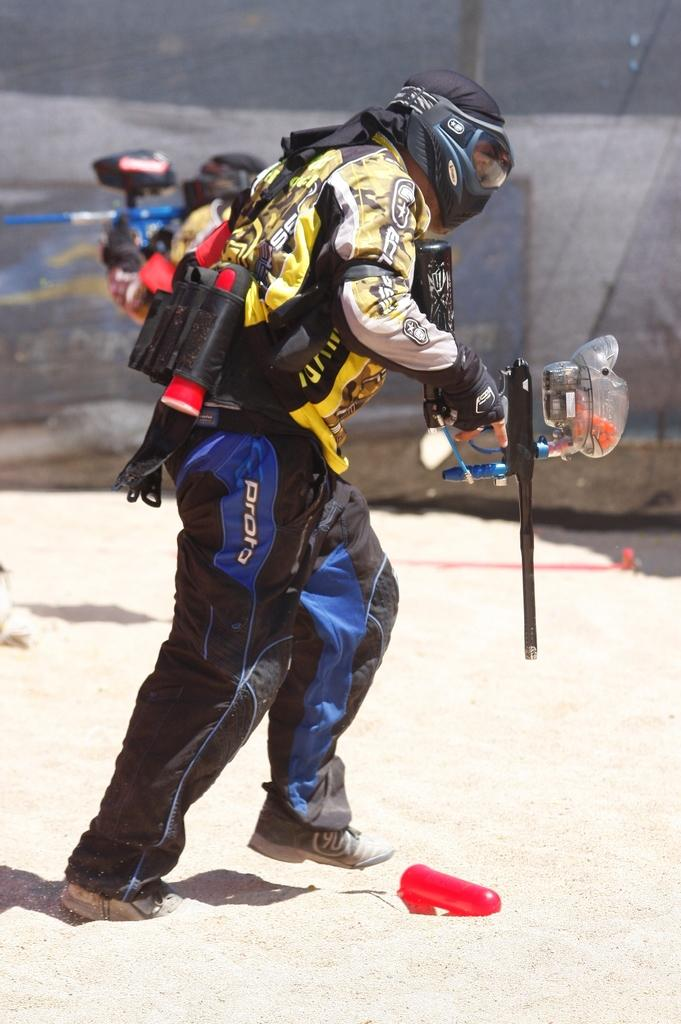What is the primary action of the person in the image? The person is walking. What is the person holding in the image? The person is holding something. What protective measures is the person taking in the image? The person is wearing a mask, gloves, and shoes. What type of surface is visible at the bottom of the image? There is sand at the bottom of the image. How would you describe the background of the image? The background of the image is blurry. What type of ornament is hanging from the person's neck in the image? There is no ornament visible around the person's neck in the image. How many pages are visible in the image? There are no pages present in the image. 